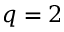Convert formula to latex. <formula><loc_0><loc_0><loc_500><loc_500>q = 2</formula> 